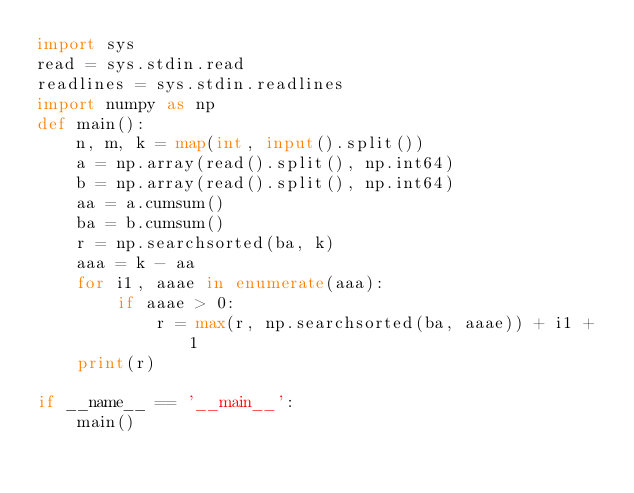Convert code to text. <code><loc_0><loc_0><loc_500><loc_500><_Python_>import sys
read = sys.stdin.read
readlines = sys.stdin.readlines
import numpy as np
def main():
    n, m, k = map(int, input().split())
    a = np.array(read().split(), np.int64)
    b = np.array(read().split(), np.int64)
    aa = a.cumsum()
    ba = b.cumsum()
    r = np.searchsorted(ba, k)
    aaa = k - aa
    for i1, aaae in enumerate(aaa):
        if aaae > 0:
            r = max(r, np.searchsorted(ba, aaae)) + i1 + 1
    print(r)

if __name__ == '__main__':
    main()</code> 